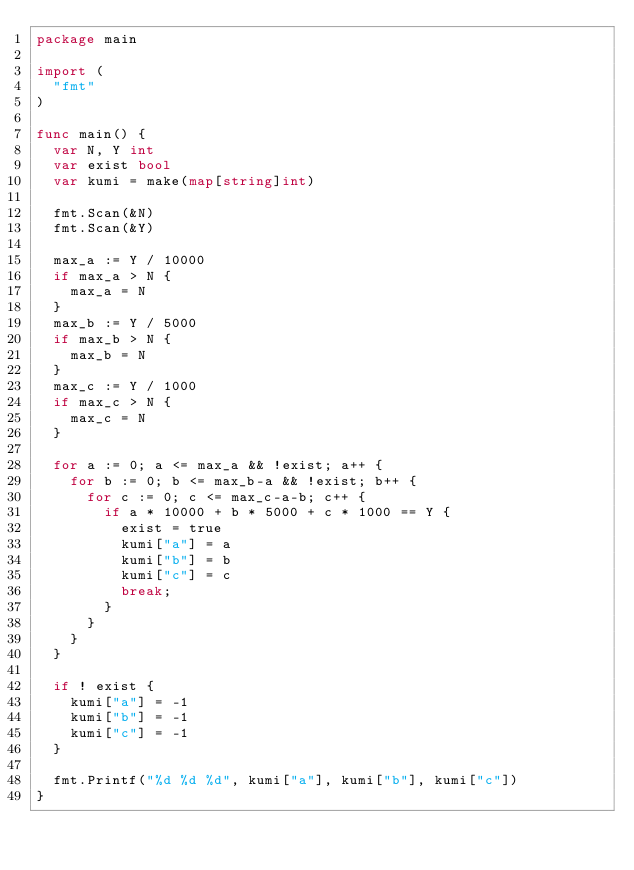<code> <loc_0><loc_0><loc_500><loc_500><_Go_>package main

import (
	"fmt"
)

func main() {
	var N, Y int
	var exist bool
	var kumi = make(map[string]int)

	fmt.Scan(&N)
	fmt.Scan(&Y)

	max_a := Y / 10000
	if max_a > N {
		max_a = N
	}
	max_b := Y / 5000
	if max_b > N {
		max_b = N
	}
	max_c := Y / 1000
	if max_c > N {
		max_c = N
	}
	
	for a := 0; a <= max_a && !exist; a++ {
		for b := 0; b <= max_b-a && !exist; b++ {
			for c := 0; c <= max_c-a-b; c++ {
				if a * 10000 + b * 5000 + c * 1000 == Y {
					exist = true
					kumi["a"] = a
					kumi["b"] = b
					kumi["c"] = c
					break;
				}
			}
		}
	}

	if ! exist {
		kumi["a"] = -1
		kumi["b"] = -1
		kumi["c"] = -1
	}

	fmt.Printf("%d %d %d", kumi["a"], kumi["b"], kumi["c"])
}</code> 